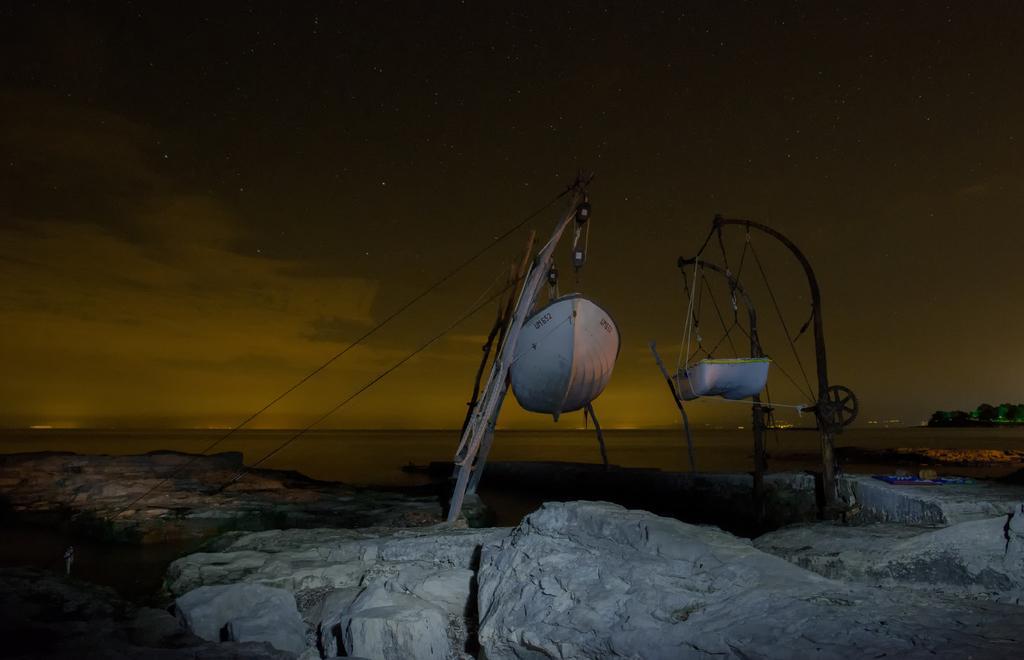How would you summarize this image in a sentence or two? In this picture, we see boats in white color. Beside that, there are wooden sticks. At the bottom of the picture, we see the rock. In the background, we see water. On the right side, there are trees. At the top of the picture, we see the sky. 